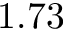<formula> <loc_0><loc_0><loc_500><loc_500>1 . 7 3</formula> 